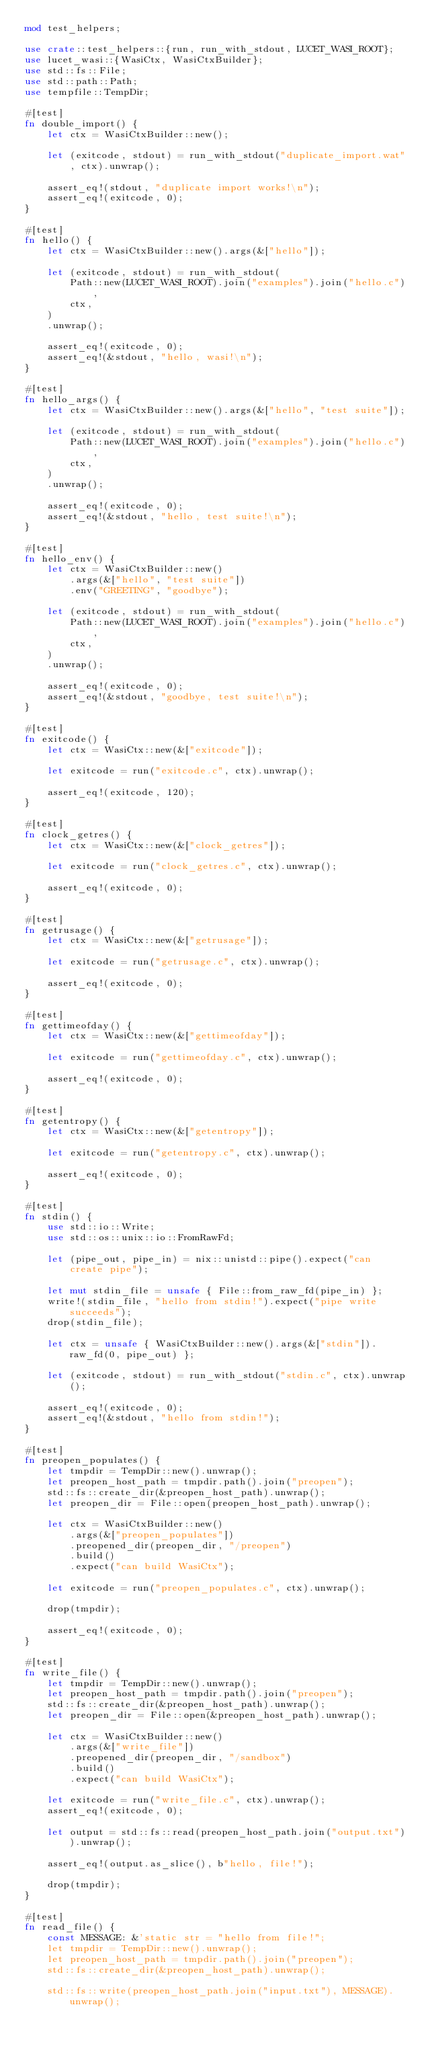<code> <loc_0><loc_0><loc_500><loc_500><_Rust_>mod test_helpers;

use crate::test_helpers::{run, run_with_stdout, LUCET_WASI_ROOT};
use lucet_wasi::{WasiCtx, WasiCtxBuilder};
use std::fs::File;
use std::path::Path;
use tempfile::TempDir;

#[test]
fn double_import() {
    let ctx = WasiCtxBuilder::new();

    let (exitcode, stdout) = run_with_stdout("duplicate_import.wat", ctx).unwrap();

    assert_eq!(stdout, "duplicate import works!\n");
    assert_eq!(exitcode, 0);
}

#[test]
fn hello() {
    let ctx = WasiCtxBuilder::new().args(&["hello"]);

    let (exitcode, stdout) = run_with_stdout(
        Path::new(LUCET_WASI_ROOT).join("examples").join("hello.c"),
        ctx,
    )
    .unwrap();

    assert_eq!(exitcode, 0);
    assert_eq!(&stdout, "hello, wasi!\n");
}

#[test]
fn hello_args() {
    let ctx = WasiCtxBuilder::new().args(&["hello", "test suite"]);

    let (exitcode, stdout) = run_with_stdout(
        Path::new(LUCET_WASI_ROOT).join("examples").join("hello.c"),
        ctx,
    )
    .unwrap();

    assert_eq!(exitcode, 0);
    assert_eq!(&stdout, "hello, test suite!\n");
}

#[test]
fn hello_env() {
    let ctx = WasiCtxBuilder::new()
        .args(&["hello", "test suite"])
        .env("GREETING", "goodbye");

    let (exitcode, stdout) = run_with_stdout(
        Path::new(LUCET_WASI_ROOT).join("examples").join("hello.c"),
        ctx,
    )
    .unwrap();

    assert_eq!(exitcode, 0);
    assert_eq!(&stdout, "goodbye, test suite!\n");
}

#[test]
fn exitcode() {
    let ctx = WasiCtx::new(&["exitcode"]);

    let exitcode = run("exitcode.c", ctx).unwrap();

    assert_eq!(exitcode, 120);
}

#[test]
fn clock_getres() {
    let ctx = WasiCtx::new(&["clock_getres"]);

    let exitcode = run("clock_getres.c", ctx).unwrap();

    assert_eq!(exitcode, 0);
}

#[test]
fn getrusage() {
    let ctx = WasiCtx::new(&["getrusage"]);

    let exitcode = run("getrusage.c", ctx).unwrap();

    assert_eq!(exitcode, 0);
}

#[test]
fn gettimeofday() {
    let ctx = WasiCtx::new(&["gettimeofday"]);

    let exitcode = run("gettimeofday.c", ctx).unwrap();

    assert_eq!(exitcode, 0);
}

#[test]
fn getentropy() {
    let ctx = WasiCtx::new(&["getentropy"]);

    let exitcode = run("getentropy.c", ctx).unwrap();

    assert_eq!(exitcode, 0);
}

#[test]
fn stdin() {
    use std::io::Write;
    use std::os::unix::io::FromRawFd;

    let (pipe_out, pipe_in) = nix::unistd::pipe().expect("can create pipe");

    let mut stdin_file = unsafe { File::from_raw_fd(pipe_in) };
    write!(stdin_file, "hello from stdin!").expect("pipe write succeeds");
    drop(stdin_file);

    let ctx = unsafe { WasiCtxBuilder::new().args(&["stdin"]).raw_fd(0, pipe_out) };

    let (exitcode, stdout) = run_with_stdout("stdin.c", ctx).unwrap();

    assert_eq!(exitcode, 0);
    assert_eq!(&stdout, "hello from stdin!");
}

#[test]
fn preopen_populates() {
    let tmpdir = TempDir::new().unwrap();
    let preopen_host_path = tmpdir.path().join("preopen");
    std::fs::create_dir(&preopen_host_path).unwrap();
    let preopen_dir = File::open(preopen_host_path).unwrap();

    let ctx = WasiCtxBuilder::new()
        .args(&["preopen_populates"])
        .preopened_dir(preopen_dir, "/preopen")
        .build()
        .expect("can build WasiCtx");

    let exitcode = run("preopen_populates.c", ctx).unwrap();

    drop(tmpdir);

    assert_eq!(exitcode, 0);
}

#[test]
fn write_file() {
    let tmpdir = TempDir::new().unwrap();
    let preopen_host_path = tmpdir.path().join("preopen");
    std::fs::create_dir(&preopen_host_path).unwrap();
    let preopen_dir = File::open(&preopen_host_path).unwrap();

    let ctx = WasiCtxBuilder::new()
        .args(&["write_file"])
        .preopened_dir(preopen_dir, "/sandbox")
        .build()
        .expect("can build WasiCtx");

    let exitcode = run("write_file.c", ctx).unwrap();
    assert_eq!(exitcode, 0);

    let output = std::fs::read(preopen_host_path.join("output.txt")).unwrap();

    assert_eq!(output.as_slice(), b"hello, file!");

    drop(tmpdir);
}

#[test]
fn read_file() {
    const MESSAGE: &'static str = "hello from file!";
    let tmpdir = TempDir::new().unwrap();
    let preopen_host_path = tmpdir.path().join("preopen");
    std::fs::create_dir(&preopen_host_path).unwrap();

    std::fs::write(preopen_host_path.join("input.txt"), MESSAGE).unwrap();
</code> 